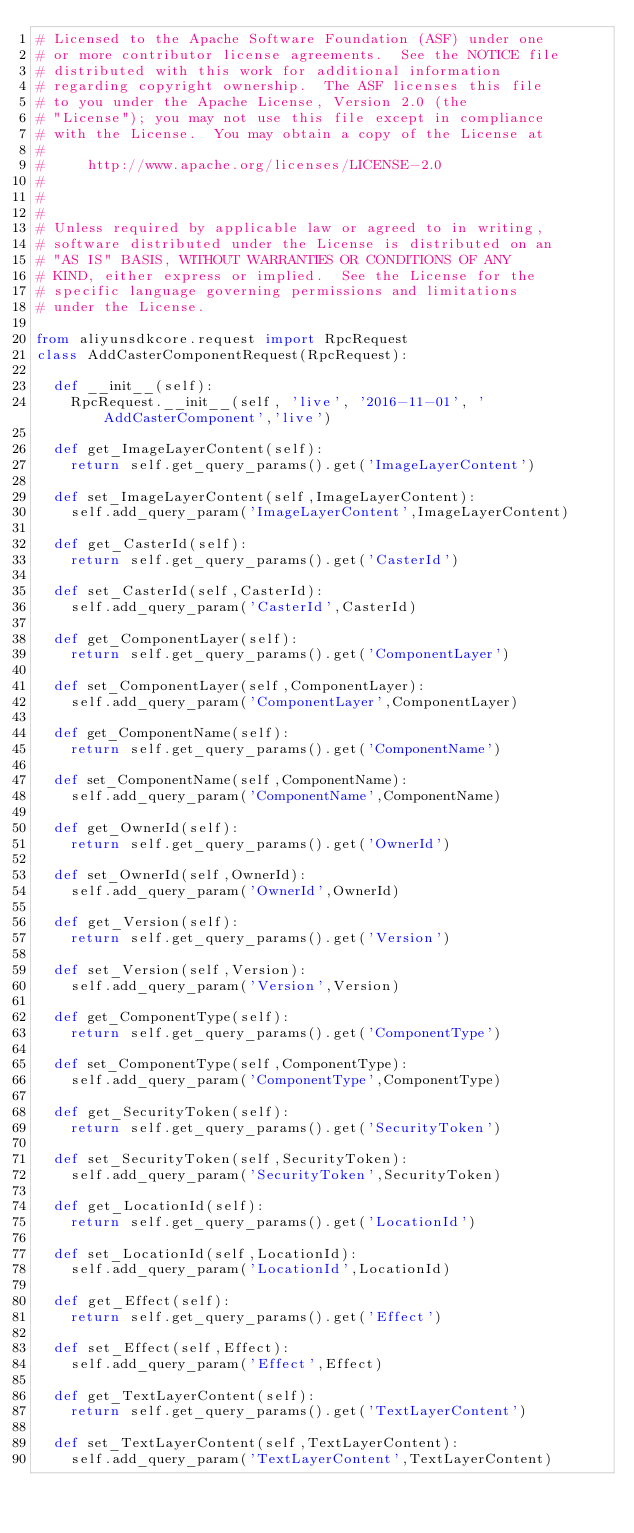<code> <loc_0><loc_0><loc_500><loc_500><_Python_># Licensed to the Apache Software Foundation (ASF) under one
# or more contributor license agreements.  See the NOTICE file
# distributed with this work for additional information
# regarding copyright ownership.  The ASF licenses this file
# to you under the Apache License, Version 2.0 (the
# "License"); you may not use this file except in compliance
# with the License.  You may obtain a copy of the License at
#
#     http://www.apache.org/licenses/LICENSE-2.0
#
#
#
# Unless required by applicable law or agreed to in writing,
# software distributed under the License is distributed on an
# "AS IS" BASIS, WITHOUT WARRANTIES OR CONDITIONS OF ANY
# KIND, either express or implied.  See the License for the
# specific language governing permissions and limitations
# under the License.

from aliyunsdkcore.request import RpcRequest
class AddCasterComponentRequest(RpcRequest):

	def __init__(self):
		RpcRequest.__init__(self, 'live', '2016-11-01', 'AddCasterComponent','live')

	def get_ImageLayerContent(self):
		return self.get_query_params().get('ImageLayerContent')

	def set_ImageLayerContent(self,ImageLayerContent):
		self.add_query_param('ImageLayerContent',ImageLayerContent)

	def get_CasterId(self):
		return self.get_query_params().get('CasterId')

	def set_CasterId(self,CasterId):
		self.add_query_param('CasterId',CasterId)

	def get_ComponentLayer(self):
		return self.get_query_params().get('ComponentLayer')

	def set_ComponentLayer(self,ComponentLayer):
		self.add_query_param('ComponentLayer',ComponentLayer)

	def get_ComponentName(self):
		return self.get_query_params().get('ComponentName')

	def set_ComponentName(self,ComponentName):
		self.add_query_param('ComponentName',ComponentName)

	def get_OwnerId(self):
		return self.get_query_params().get('OwnerId')

	def set_OwnerId(self,OwnerId):
		self.add_query_param('OwnerId',OwnerId)

	def get_Version(self):
		return self.get_query_params().get('Version')

	def set_Version(self,Version):
		self.add_query_param('Version',Version)

	def get_ComponentType(self):
		return self.get_query_params().get('ComponentType')

	def set_ComponentType(self,ComponentType):
		self.add_query_param('ComponentType',ComponentType)

	def get_SecurityToken(self):
		return self.get_query_params().get('SecurityToken')

	def set_SecurityToken(self,SecurityToken):
		self.add_query_param('SecurityToken',SecurityToken)

	def get_LocationId(self):
		return self.get_query_params().get('LocationId')

	def set_LocationId(self,LocationId):
		self.add_query_param('LocationId',LocationId)

	def get_Effect(self):
		return self.get_query_params().get('Effect')

	def set_Effect(self,Effect):
		self.add_query_param('Effect',Effect)

	def get_TextLayerContent(self):
		return self.get_query_params().get('TextLayerContent')

	def set_TextLayerContent(self,TextLayerContent):
		self.add_query_param('TextLayerContent',TextLayerContent)</code> 